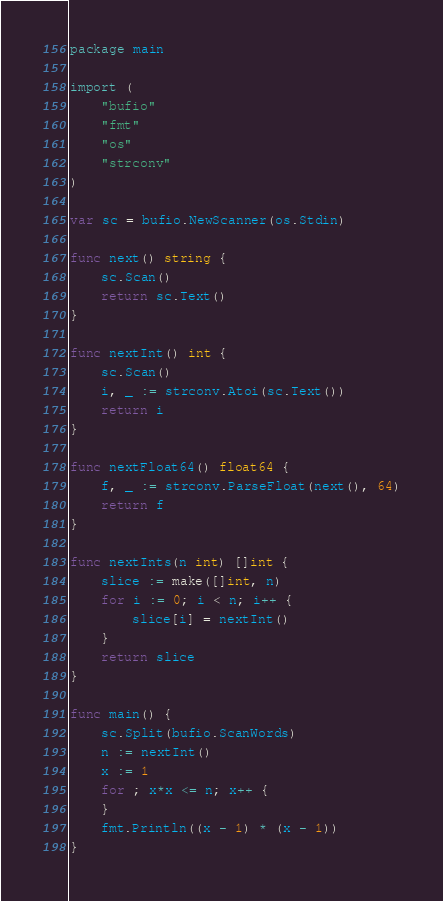Convert code to text. <code><loc_0><loc_0><loc_500><loc_500><_Go_>package main

import (
	"bufio"
	"fmt"
	"os"
	"strconv"
)

var sc = bufio.NewScanner(os.Stdin)

func next() string {
	sc.Scan()
	return sc.Text()
}

func nextInt() int {
	sc.Scan()
	i, _ := strconv.Atoi(sc.Text())
	return i
}

func nextFloat64() float64 {
	f, _ := strconv.ParseFloat(next(), 64)
	return f
}

func nextInts(n int) []int {
	slice := make([]int, n)
	for i := 0; i < n; i++ {
		slice[i] = nextInt()
	}
	return slice
}

func main() {
	sc.Split(bufio.ScanWords)
	n := nextInt()
	x := 1
	for ; x*x <= n; x++ {
	}
	fmt.Println((x - 1) * (x - 1))
}
</code> 